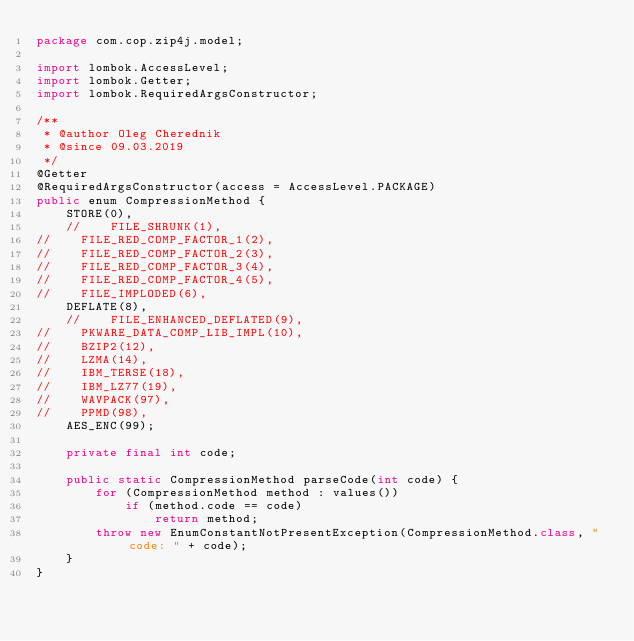<code> <loc_0><loc_0><loc_500><loc_500><_Java_>package com.cop.zip4j.model;

import lombok.AccessLevel;
import lombok.Getter;
import lombok.RequiredArgsConstructor;

/**
 * @author Oleg Cherednik
 * @since 09.03.2019
 */
@Getter
@RequiredArgsConstructor(access = AccessLevel.PACKAGE)
public enum CompressionMethod {
    STORE(0),
    //    FILE_SHRUNK(1),
//    FILE_RED_COMP_FACTOR_1(2),
//    FILE_RED_COMP_FACTOR_2(3),
//    FILE_RED_COMP_FACTOR_3(4),
//    FILE_RED_COMP_FACTOR_4(5),
//    FILE_IMPLODED(6),
    DEFLATE(8),
    //    FILE_ENHANCED_DEFLATED(9),
//    PKWARE_DATA_COMP_LIB_IMPL(10),
//    BZIP2(12),
//    LZMA(14),
//    IBM_TERSE(18),
//    IBM_LZ77(19),
//    WAVPACK(97),
//    PPMD(98),
    AES_ENC(99);

    private final int code;

    public static CompressionMethod parseCode(int code) {
        for (CompressionMethod method : values())
            if (method.code == code)
                return method;
        throw new EnumConstantNotPresentException(CompressionMethod.class, "code: " + code);
    }
}
</code> 